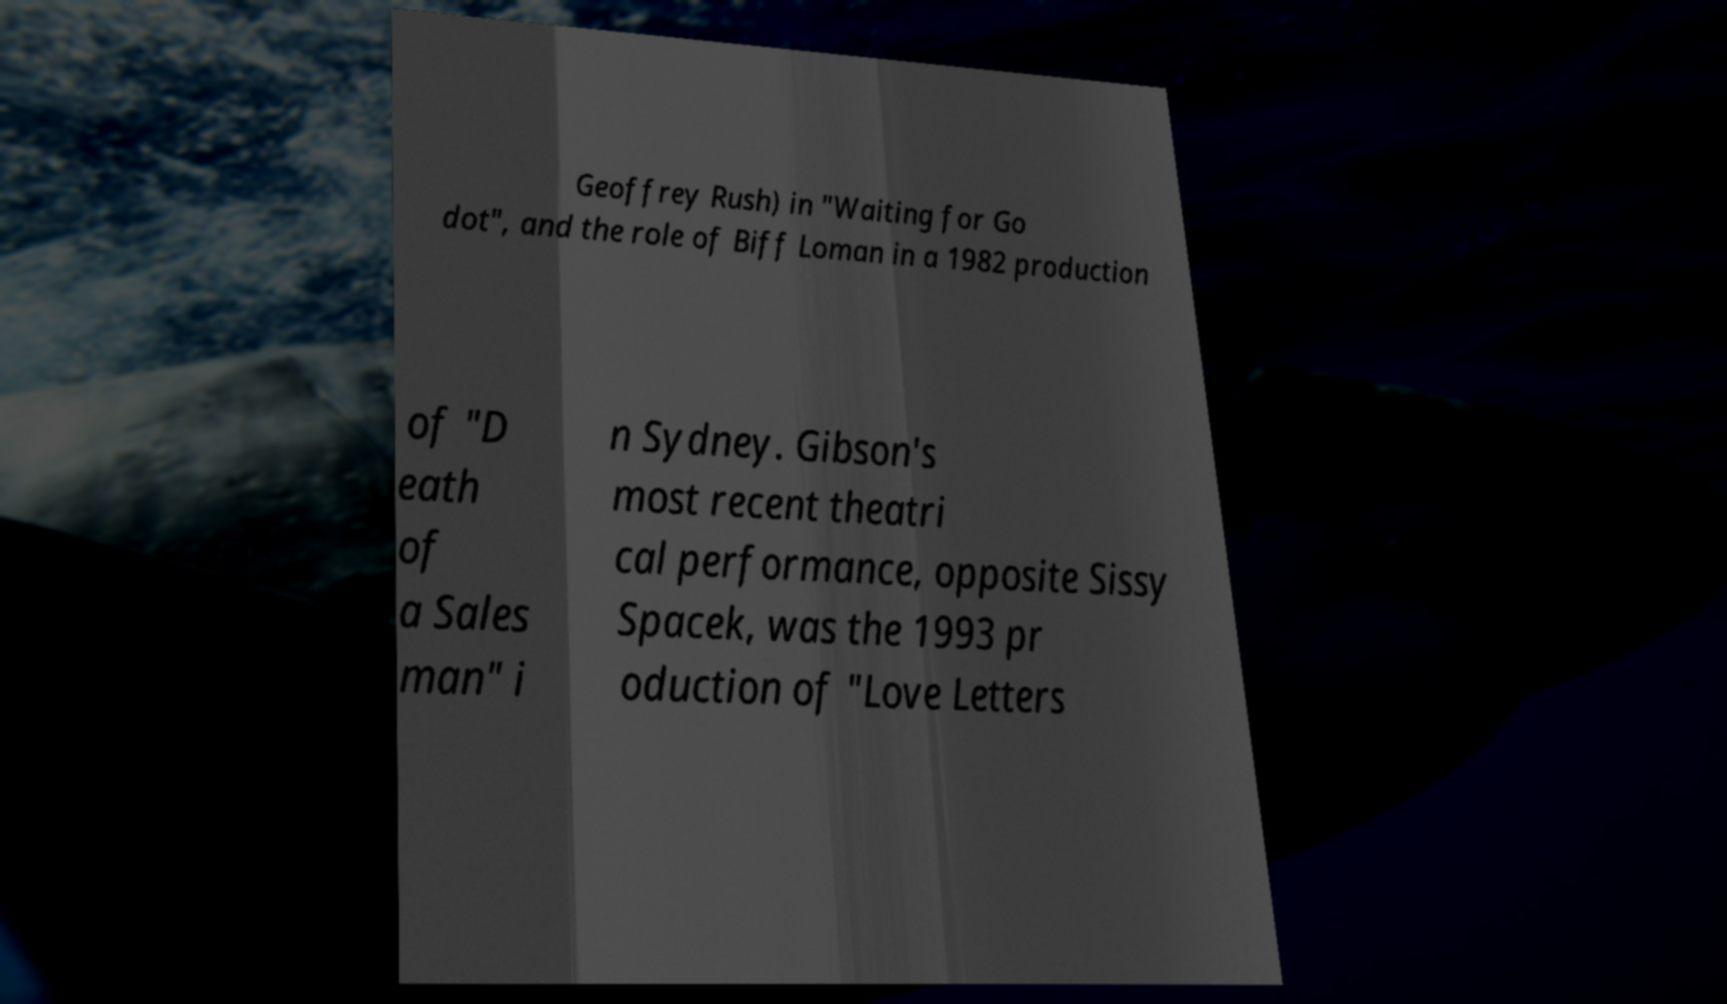What messages or text are displayed in this image? I need them in a readable, typed format. Geoffrey Rush) in "Waiting for Go dot", and the role of Biff Loman in a 1982 production of "D eath of a Sales man" i n Sydney. Gibson's most recent theatri cal performance, opposite Sissy Spacek, was the 1993 pr oduction of "Love Letters 